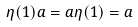<formula> <loc_0><loc_0><loc_500><loc_500>\eta ( 1 ) a = a \eta ( 1 ) = a</formula> 